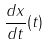<formula> <loc_0><loc_0><loc_500><loc_500>\frac { d x } { d t } ( t )</formula> 